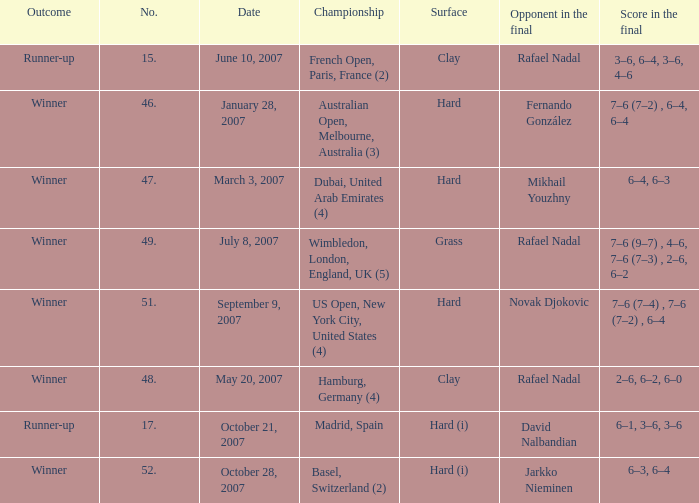On the date October 21, 2007, what is the No.? 17.0. 